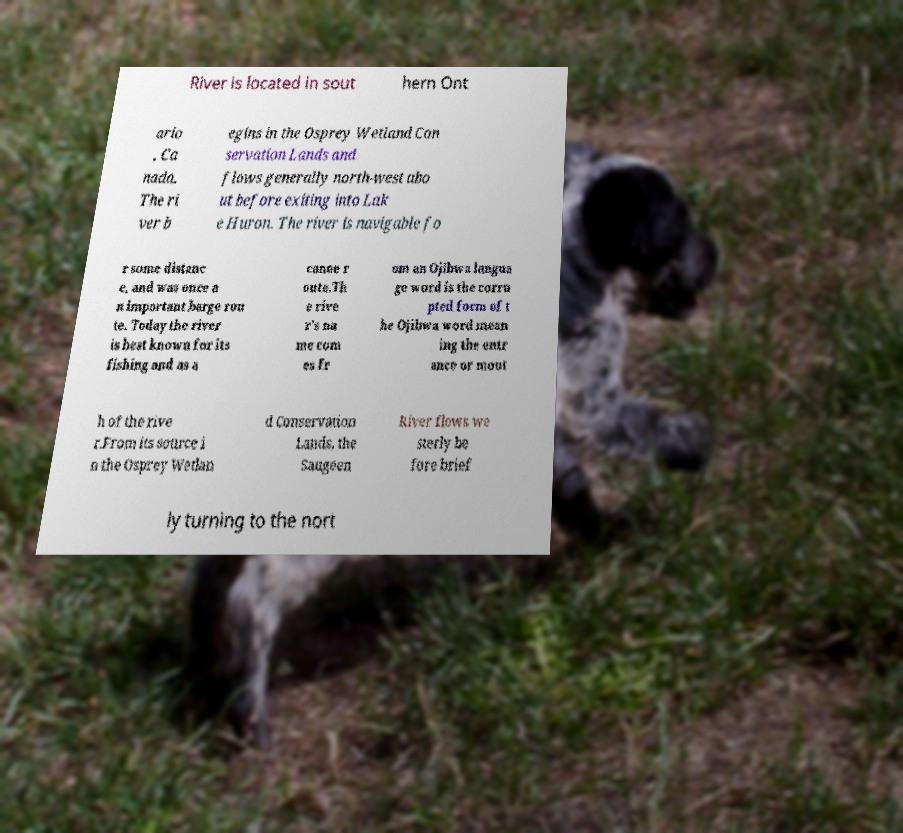Please identify and transcribe the text found in this image. River is located in sout hern Ont ario , Ca nada. The ri ver b egins in the Osprey Wetland Con servation Lands and flows generally north-west abo ut before exiting into Lak e Huron. The river is navigable fo r some distanc e, and was once a n important barge rou te. Today the river is best known for its fishing and as a canoe r oute.Th e rive r's na me com es fr om an Ojibwa langua ge word is the corru pted form of t he Ojibwa word mean ing the entr ance or mout h of the rive r.From its source i n the Osprey Wetlan d Conservation Lands, the Saugeen River flows we sterly be fore brief ly turning to the nort 